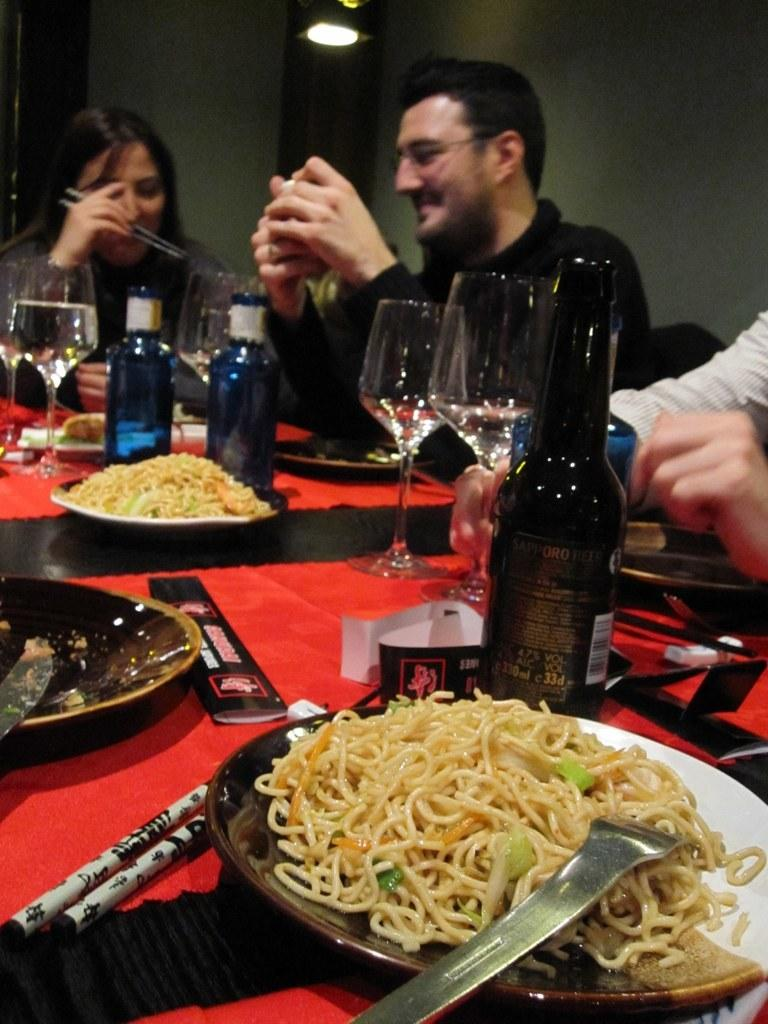What is on the plate that is visible in the image? There is food on the plate in the image. What other items can be seen on the table in the image? There are bottles and glasses visible on the table in the image. Where are the plate, food, bottles, and glasses located in the image? The plate, food, bottles, and glasses are on a table in the image. How many people are seated in front of the table in the image? There are three people seated on chairs in front of the table in the image. What type of curtain can be seen hanging in the background of the image? There is no curtain visible in the image; it only shows a table with a plate of food, bottles, and glasses, as well as three people seated in front of the table. 